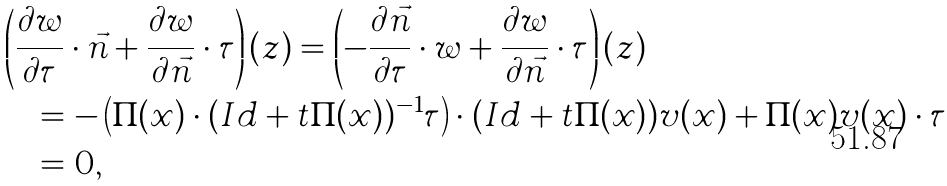Convert formula to latex. <formula><loc_0><loc_0><loc_500><loc_500>& \left ( \frac { \partial w } { \partial \tau } \cdot \vec { n } + \frac { \partial w } { \partial \vec { n } } \cdot \tau \right ) ( z ) = \left ( - \frac { \partial \vec { n } } { \partial \tau } \cdot w + \frac { \partial w } { \partial \vec { n } } \cdot \tau \right ) ( z ) \\ & \quad = - \left ( \Pi ( x ) \cdot ( I d + t \Pi ( x ) ) ^ { - 1 } \tau \right ) \cdot ( I d + t \Pi ( x ) ) v ( x ) + \Pi ( x ) v ( x ) \cdot \tau \\ & \quad = 0 ,</formula> 